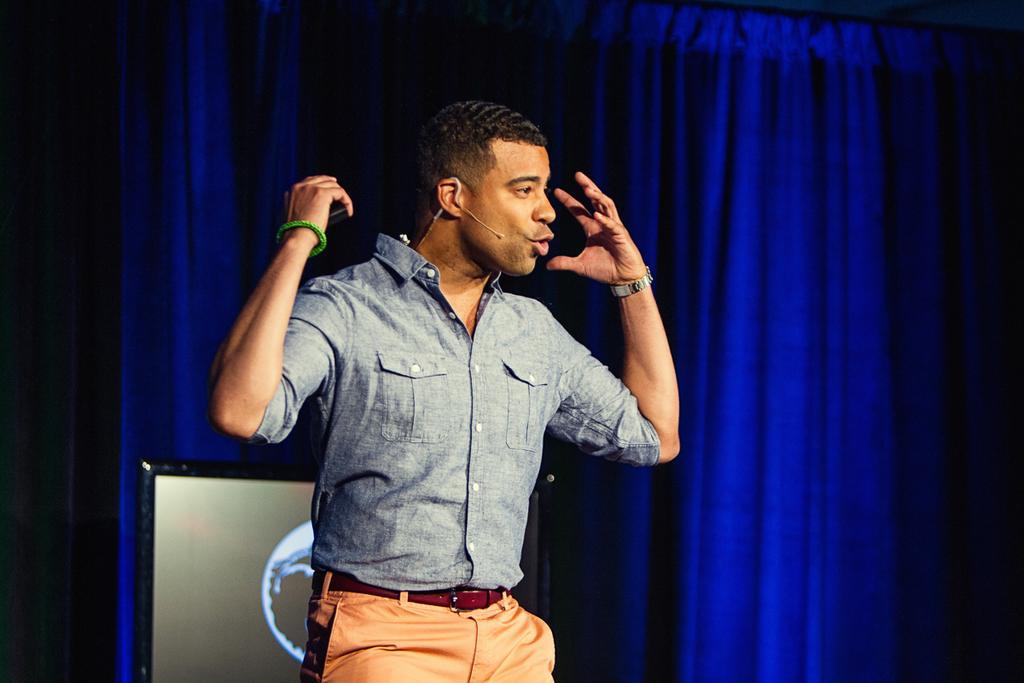In one or two sentences, can you explain what this image depicts? In this image we can see a man standing holding an object. On the backside we can see a display screen and a curtain. 